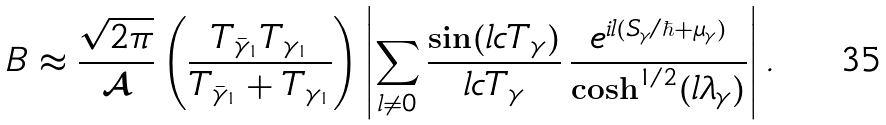Convert formula to latex. <formula><loc_0><loc_0><loc_500><loc_500>\ B \approx \frac { \sqrt { 2 \pi } } { \mathcal { A } } \left ( \frac { T _ { \bar { \gamma } _ { 1 } } T _ { \gamma _ { 1 } } } { T _ { \bar { \gamma } _ { 1 } } + T _ { \gamma _ { 1 } } } \right ) \left | \sum _ { l \neq 0 } \frac { \sin ( l c T _ { \gamma } ) } { l c T _ { \gamma } } \, \frac { e ^ { i l ( S _ { \gamma } / \hbar { + } \mu _ { \gamma } ) } } { \cosh ^ { 1 / 2 } ( l \lambda _ { \gamma } ) } \right | .</formula> 